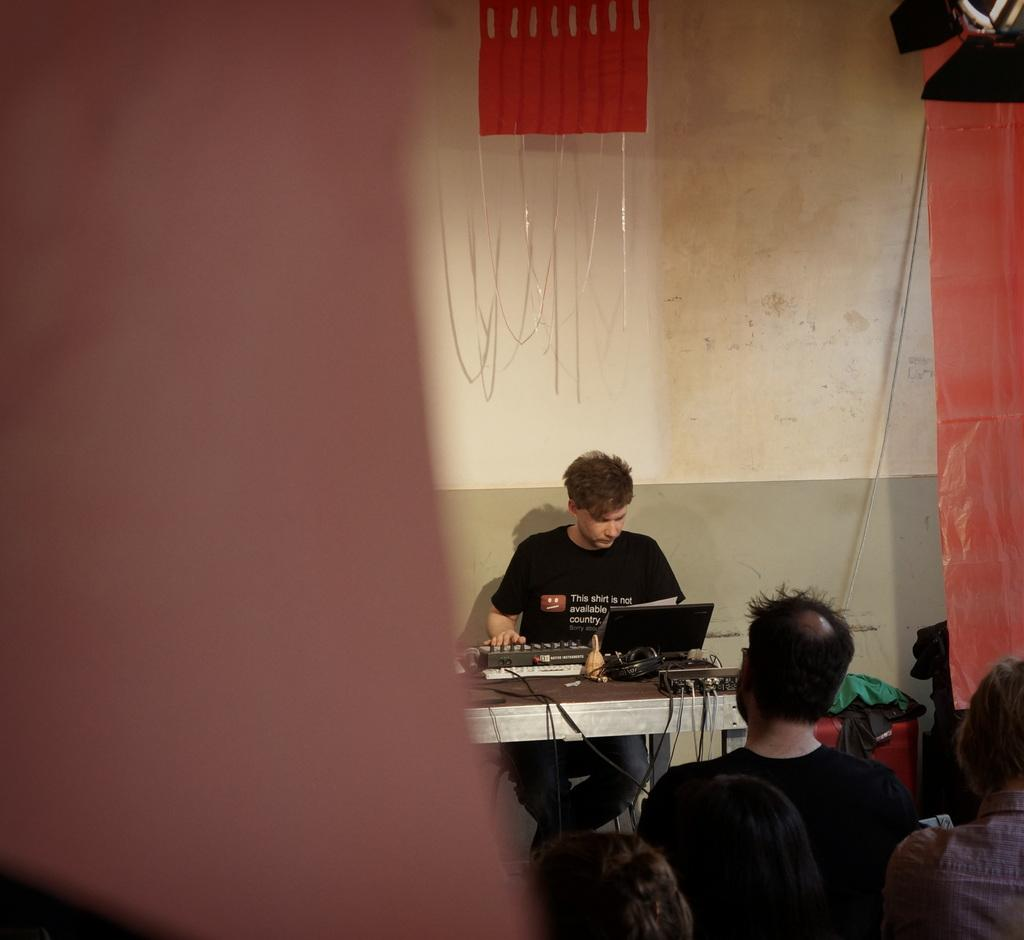How many people are in the image? There is a group of people in the image. What is one person in the group doing? One person is seated on a chair. What is the seated person doing while on the chair? The seated person is operating a machine. Where is the machine located? The machine is on a table. What type of winter ornament is hanging from the ceiling in the image? There is no mention of a winter ornament or any ornaments in the image. 